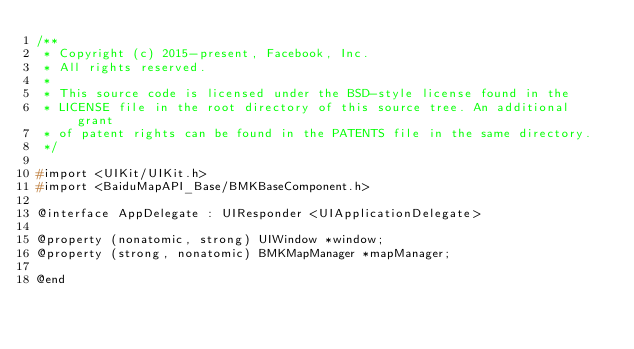Convert code to text. <code><loc_0><loc_0><loc_500><loc_500><_C_>/**
 * Copyright (c) 2015-present, Facebook, Inc.
 * All rights reserved.
 *
 * This source code is licensed under the BSD-style license found in the
 * LICENSE file in the root directory of this source tree. An additional grant
 * of patent rights can be found in the PATENTS file in the same directory.
 */

#import <UIKit/UIKit.h>
#import <BaiduMapAPI_Base/BMKBaseComponent.h>

@interface AppDelegate : UIResponder <UIApplicationDelegate>

@property (nonatomic, strong) UIWindow *window;
@property (strong, nonatomic) BMKMapManager *mapManager;

@end
</code> 